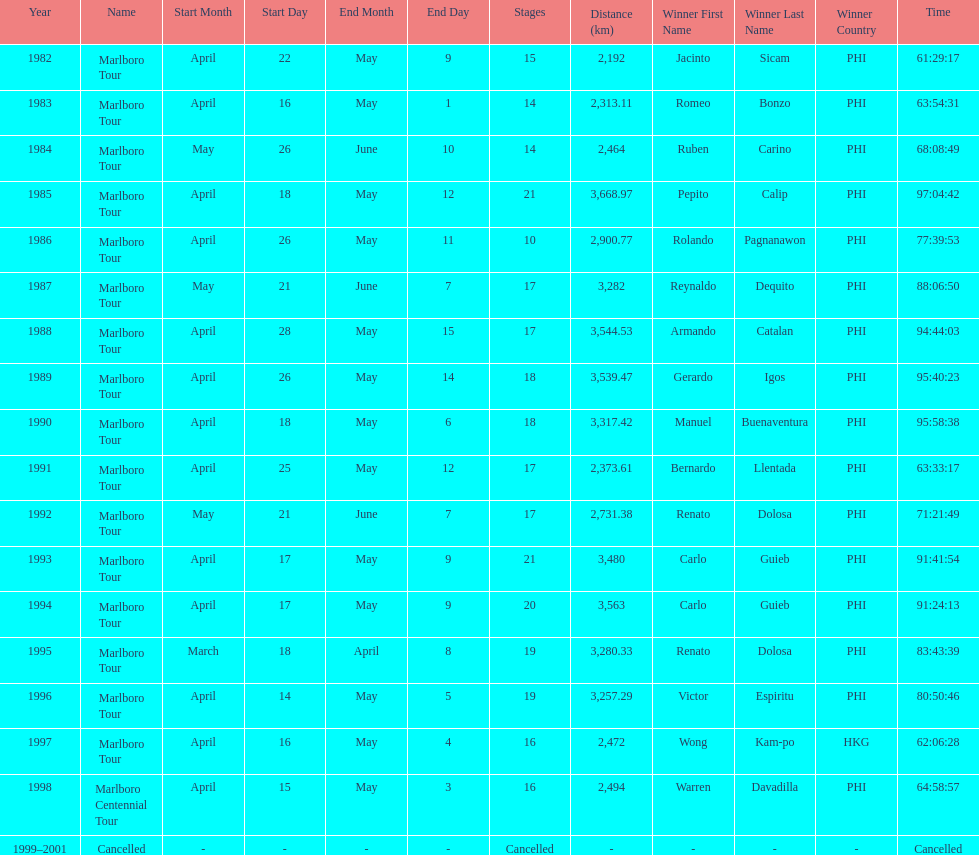What was the largest distance traveled for the marlboro tour? 3,668.97 km. 